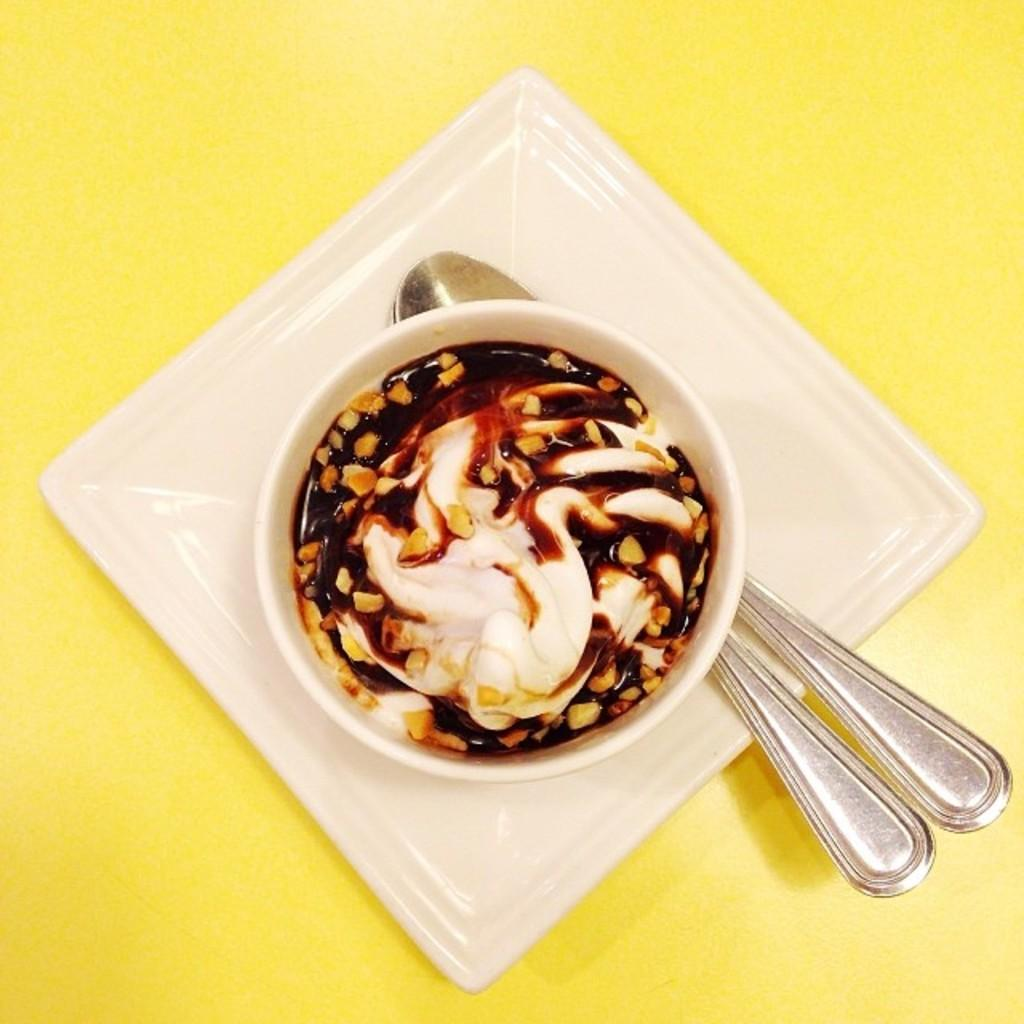What is in the bowl that is visible in the image? There is food in a bowl in the image. What else can be seen on the plate in the image? There are spoons on a plate in the image. Where are the food and spoons located? The food and spoons are kept on a desk in the image. What is the color of the desk? The desk is yellow in color. How does the donkey contribute to the development of the quarter in the image? There is no donkey or development of a quarter present in the image. 